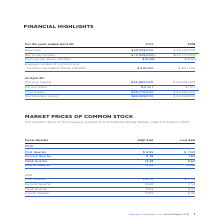According to Frequency Electronics's financial document, Which global market is the common stock of the Company listed on? According to the financial document, NASDAQ. The relevant text states: "The common stock of the Company is listed on the NASDAQ Global Market under the symbol “FEIM.”..." Also, What symbol is the common stock trading under? According to the financial document, FEIM. The relevant text states: "ted on the NASDAQ Global Market under the symbol “FEIM.”..." Also, What is the high sale and low sale of the first quarter of 2019 respectively? The document shows two values: $8.95 and $7.30. From the document: "First Quarter $ 8.95 $ 7.30 First Quarter $ 8.95 $ 7.30..." Also, can you calculate: What is the difference in the high and low sale of the first quarter in 2019? Based on the calculation: 8.95-7.30, the result is 1.65. This is based on the information: "First Quarter $ 8.95 $ 7.30 First Quarter $ 8.95 $ 7.30..." The key data points involved are: 7.30, 8.95. Also, can you calculate: What is the average quarterly low sale price for 2019? To answer this question, I need to perform calculations using the financial data. The calculation is: (7.30+7.80+9.60+10.80)/4, which equals 8.88. This is based on the information: "Third Quarter 13.38 9.60 Fourth Quarter 13.52 10.80 First Quarter $ 8.95 $ 7.30 Second Quarter 11.38 7.80..." The key data points involved are: 10.80, 7.30, 7.80. Also, can you calculate: What is the average quarterly high sale price for 2019? To answer this question, I need to perform calculations using the financial data. The calculation is: (8.95+11.38+13.38+13.52)/4, which equals 11.81. This is based on the information: "Second Quarter 11.38 7.80 First Quarter $ 8.95 $ 7.30 Third Quarter 13.38 9.60 Fourth Quarter 13.52 10.80..." The key data points involved are: 11.38, 13.38, 13.52. 